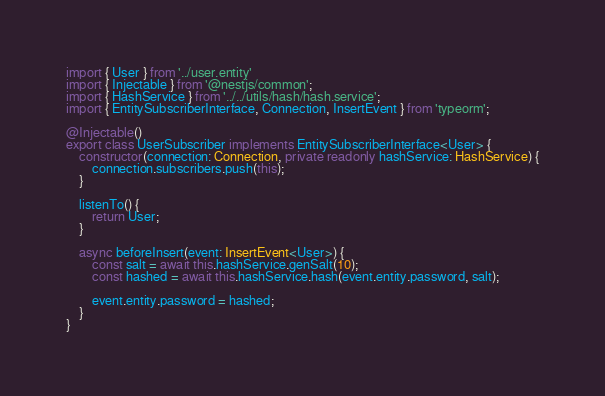<code> <loc_0><loc_0><loc_500><loc_500><_TypeScript_>import { User } from '../user.entity'
import { Injectable } from '@nestjs/common';
import { HashService } from '../../utils/hash/hash.service';
import { EntitySubscriberInterface, Connection, InsertEvent } from 'typeorm';

@Injectable()
export class UserSubscriber implements EntitySubscriberInterface<User> {
    constructor(connection: Connection, private readonly hashService: HashService) {
        connection.subscribers.push(this);
    }

    listenTo() {
        return User;
    }

    async beforeInsert(event: InsertEvent<User>) {
        const salt = await this.hashService.genSalt(10);
        const hashed = await this.hashService.hash(event.entity.password, salt);

        event.entity.password = hashed;
    }
}
</code> 